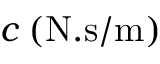Convert formula to latex. <formula><loc_0><loc_0><loc_500><loc_500>c \, ( N . s / m )</formula> 